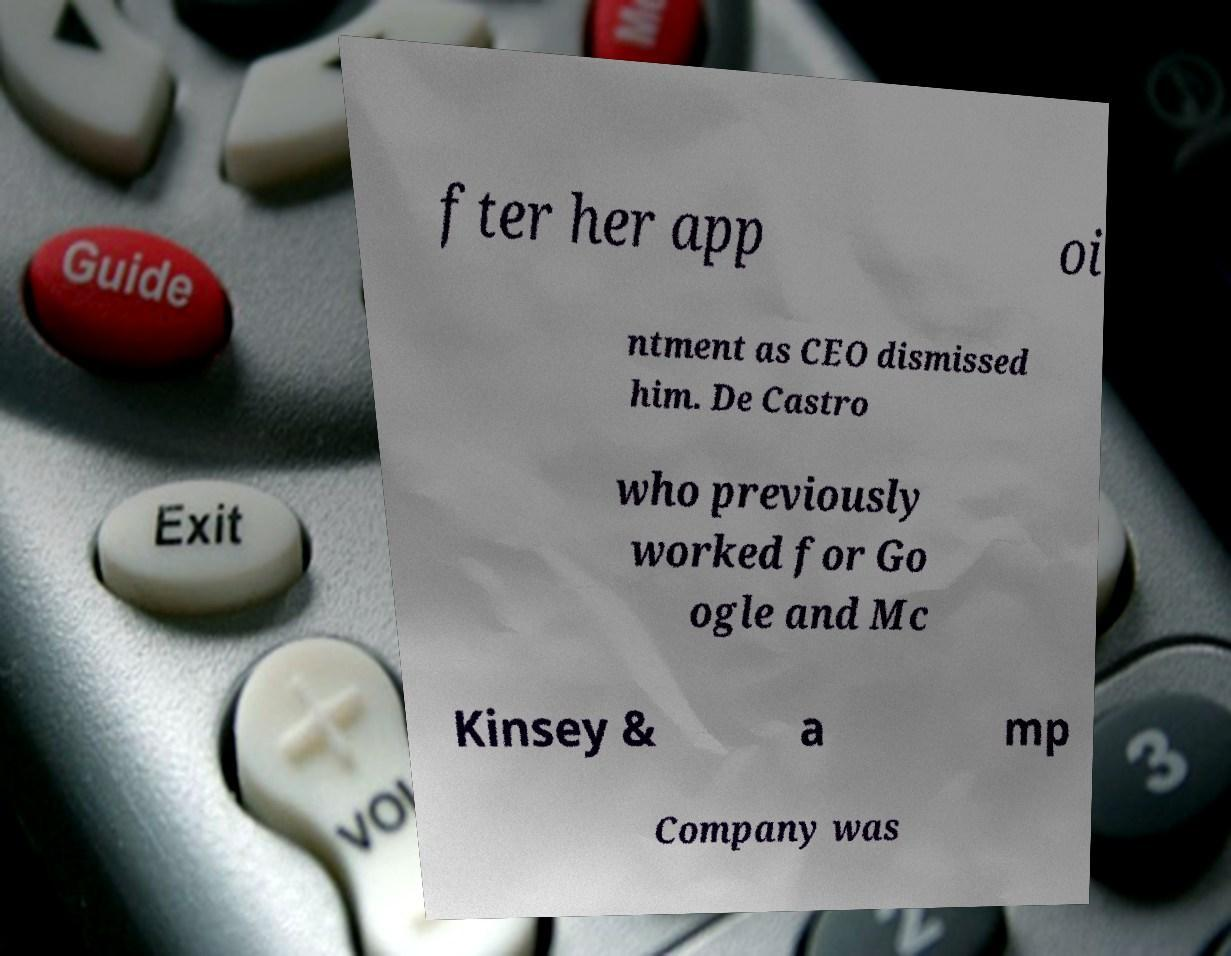Can you accurately transcribe the text from the provided image for me? fter her app oi ntment as CEO dismissed him. De Castro who previously worked for Go ogle and Mc Kinsey & a mp Company was 